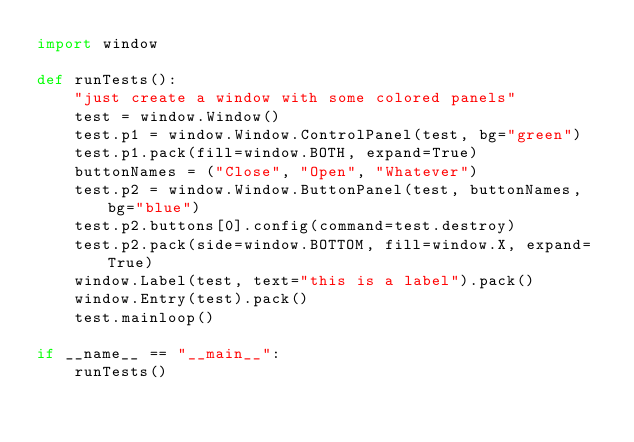<code> <loc_0><loc_0><loc_500><loc_500><_Python_>import window

def runTests():
    "just create a window with some colored panels"
    test = window.Window()
    test.p1 = window.Window.ControlPanel(test, bg="green")
    test.p1.pack(fill=window.BOTH, expand=True)
    buttonNames = ("Close", "Open", "Whatever")
    test.p2 = window.Window.ButtonPanel(test, buttonNames, bg="blue")
    test.p2.buttons[0].config(command=test.destroy)
    test.p2.pack(side=window.BOTTOM, fill=window.X, expand=True)
    window.Label(test, text="this is a label").pack()
    window.Entry(test).pack()
    test.mainloop()

if __name__ == "__main__":
    runTests()

</code> 